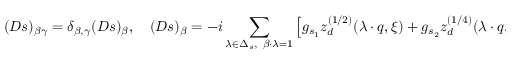Convert formula to latex. <formula><loc_0><loc_0><loc_500><loc_500>( D s ) _ { \beta \gamma } = \delta _ { \beta , \gamma } ( D s ) _ { \beta } , \quad ( D s ) _ { \beta } = - i \sum _ { \lambda \in \Delta _ { s } , \ \beta \cdot \lambda = 1 } \left [ g _ { s _ { 1 } } z _ { d } ^ { ( 1 / 2 ) } ( \lambda \cdot q , \xi ) + g _ { s _ { 2 } } z _ { d } ^ { ( 1 / 4 ) } ( \lambda \cdot q , \xi ) \right ] ,</formula> 